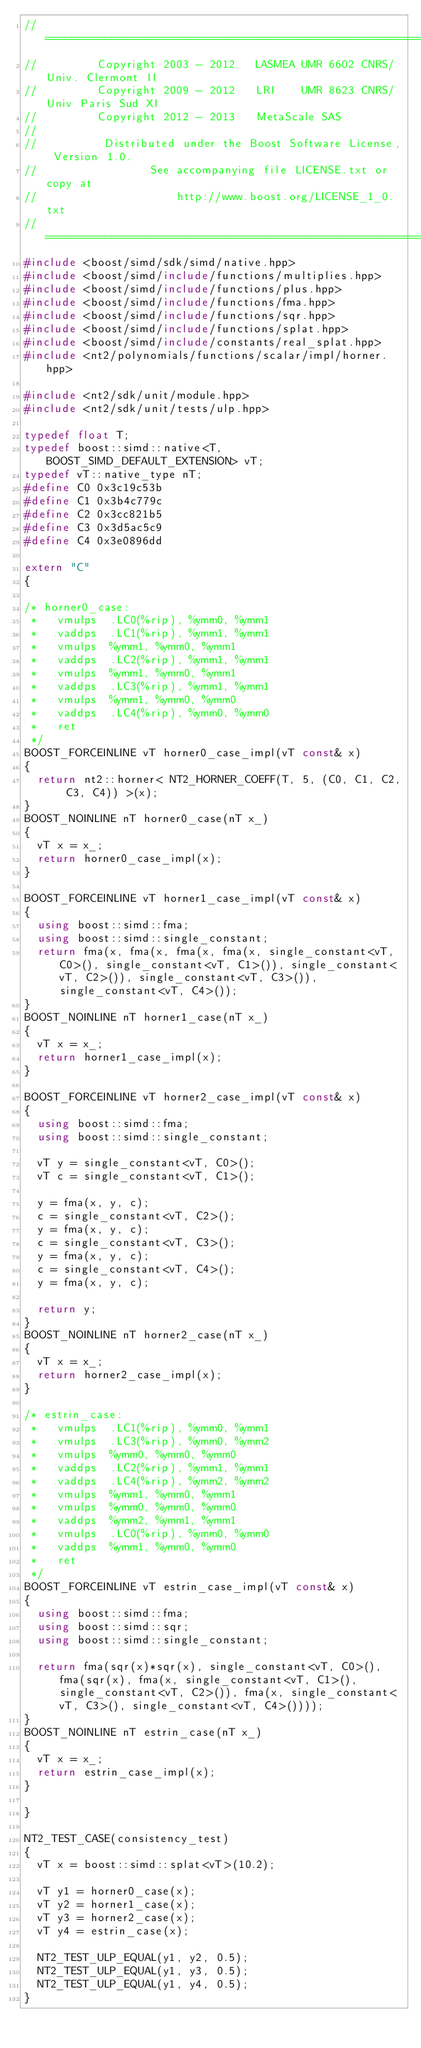<code> <loc_0><loc_0><loc_500><loc_500><_C++_>//==============================================================================
//         Copyright 2003 - 2012   LASMEA UMR 6602 CNRS/Univ. Clermont II
//         Copyright 2009 - 2012   LRI    UMR 8623 CNRS/Univ Paris Sud XI
//         Copyright 2012 - 2013   MetaScale SAS
//
//          Distributed under the Boost Software License, Version 1.0.
//                 See accompanying file LICENSE.txt or copy at
//                     http://www.boost.org/LICENSE_1_0.txt
//==============================================================================
#include <boost/simd/sdk/simd/native.hpp>
#include <boost/simd/include/functions/multiplies.hpp>
#include <boost/simd/include/functions/plus.hpp>
#include <boost/simd/include/functions/fma.hpp>
#include <boost/simd/include/functions/sqr.hpp>
#include <boost/simd/include/functions/splat.hpp>
#include <boost/simd/include/constants/real_splat.hpp>
#include <nt2/polynomials/functions/scalar/impl/horner.hpp>

#include <nt2/sdk/unit/module.hpp>
#include <nt2/sdk/unit/tests/ulp.hpp>

typedef float T;
typedef boost::simd::native<T, BOOST_SIMD_DEFAULT_EXTENSION> vT;
typedef vT::native_type nT;
#define C0 0x3c19c53b
#define C1 0x3b4c779c
#define C2 0x3cc821b5
#define C3 0x3d5ac5c9
#define C4 0x3e0896dd

extern "C"
{

/* horner0_case:
 *   vmulps  .LC0(%rip), %ymm0, %ymm1
 *   vaddps  .LC1(%rip), %ymm1, %ymm1
 *   vmulps  %ymm1, %ymm0, %ymm1
 *   vaddps  .LC2(%rip), %ymm1, %ymm1
 *   vmulps  %ymm1, %ymm0, %ymm1
 *   vaddps  .LC3(%rip), %ymm1, %ymm1
 *   vmulps  %ymm1, %ymm0, %ymm0
 *   vaddps  .LC4(%rip), %ymm0, %ymm0
 *   ret
 */
BOOST_FORCEINLINE vT horner0_case_impl(vT const& x)
{
  return nt2::horner< NT2_HORNER_COEFF(T, 5, (C0, C1, C2, C3, C4)) >(x);
}
BOOST_NOINLINE nT horner0_case(nT x_)
{
  vT x = x_;
  return horner0_case_impl(x);
}

BOOST_FORCEINLINE vT horner1_case_impl(vT const& x)
{
  using boost::simd::fma;
  using boost::simd::single_constant;
  return fma(x, fma(x, fma(x, fma(x, single_constant<vT, C0>(), single_constant<vT, C1>()), single_constant<vT, C2>()), single_constant<vT, C3>()), single_constant<vT, C4>());
}
BOOST_NOINLINE nT horner1_case(nT x_)
{
  vT x = x_;
  return horner1_case_impl(x);
}

BOOST_FORCEINLINE vT horner2_case_impl(vT const& x)
{
  using boost::simd::fma;
  using boost::simd::single_constant;

  vT y = single_constant<vT, C0>();
  vT c = single_constant<vT, C1>();

  y = fma(x, y, c);
  c = single_constant<vT, C2>();
  y = fma(x, y, c);
  c = single_constant<vT, C3>();
  y = fma(x, y, c);
  c = single_constant<vT, C4>();
  y = fma(x, y, c);

  return y;
}
BOOST_NOINLINE nT horner2_case(nT x_)
{
  vT x = x_;
  return horner2_case_impl(x);
}

/* estrin_case:
 *   vmulps  .LC1(%rip), %ymm0, %ymm1
 *   vmulps  .LC3(%rip), %ymm0, %ymm2
 *   vmulps  %ymm0, %ymm0, %ymm0
 *   vaddps  .LC2(%rip), %ymm1, %ymm1
 *   vaddps  .LC4(%rip), %ymm2, %ymm2
 *   vmulps  %ymm1, %ymm0, %ymm1
 *   vmulps  %ymm0, %ymm0, %ymm0
 *   vaddps  %ymm2, %ymm1, %ymm1
 *   vmulps  .LC0(%rip), %ymm0, %ymm0
 *   vaddps  %ymm1, %ymm0, %ymm0
 *   ret
 */
BOOST_FORCEINLINE vT estrin_case_impl(vT const& x)
{
  using boost::simd::fma;
  using boost::simd::sqr;
  using boost::simd::single_constant;

  return fma(sqr(x)*sqr(x), single_constant<vT, C0>(), fma(sqr(x), fma(x, single_constant<vT, C1>(), single_constant<vT, C2>()), fma(x, single_constant<vT, C3>(), single_constant<vT, C4>())));
}
BOOST_NOINLINE nT estrin_case(nT x_)
{
  vT x = x_;
  return estrin_case_impl(x);
}

}

NT2_TEST_CASE(consistency_test)
{
  vT x = boost::simd::splat<vT>(10.2);

  vT y1 = horner0_case(x);
  vT y2 = horner1_case(x);
  vT y3 = horner2_case(x);
  vT y4 = estrin_case(x);

  NT2_TEST_ULP_EQUAL(y1, y2, 0.5);
  NT2_TEST_ULP_EQUAL(y1, y3, 0.5);
  NT2_TEST_ULP_EQUAL(y1, y4, 0.5);
}
</code> 